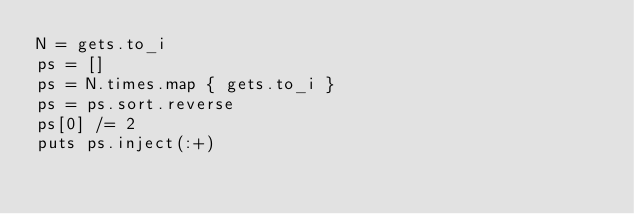Convert code to text. <code><loc_0><loc_0><loc_500><loc_500><_Ruby_>N = gets.to_i
ps = []
ps = N.times.map { gets.to_i }
ps = ps.sort.reverse
ps[0] /= 2
puts ps.inject(:+)
</code> 